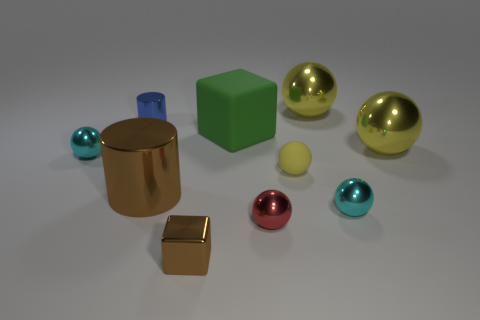Are there more blue cubes than red objects?
Give a very brief answer. No. What number of balls are the same material as the large green block?
Give a very brief answer. 1. Does the tiny red thing have the same shape as the small blue metal object?
Ensure brevity in your answer.  No. How big is the cyan sphere in front of the cyan metal ball that is left of the rubber thing that is to the right of the tiny red shiny object?
Provide a short and direct response. Small. Are there any large cylinders that are on the right side of the big shiny object on the left side of the small cube?
Ensure brevity in your answer.  No. There is a small ball on the left side of the cube behind the red metallic object; how many shiny spheres are behind it?
Your answer should be compact. 2. What is the color of the large shiny object that is both behind the large brown thing and in front of the small blue cylinder?
Your answer should be compact. Yellow. How many small rubber balls have the same color as the tiny block?
Give a very brief answer. 0. How many spheres are tiny brown objects or shiny objects?
Give a very brief answer. 5. There is a matte ball that is the same size as the red metallic ball; what is its color?
Provide a short and direct response. Yellow. 